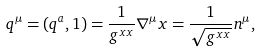<formula> <loc_0><loc_0><loc_500><loc_500>q ^ { \mu } = ( q ^ { a } , 1 ) = \frac { 1 } { g ^ { x x } } \nabla ^ { \mu } x = \frac { 1 } { \sqrt { g ^ { x x } } } n ^ { \mu } ,</formula> 